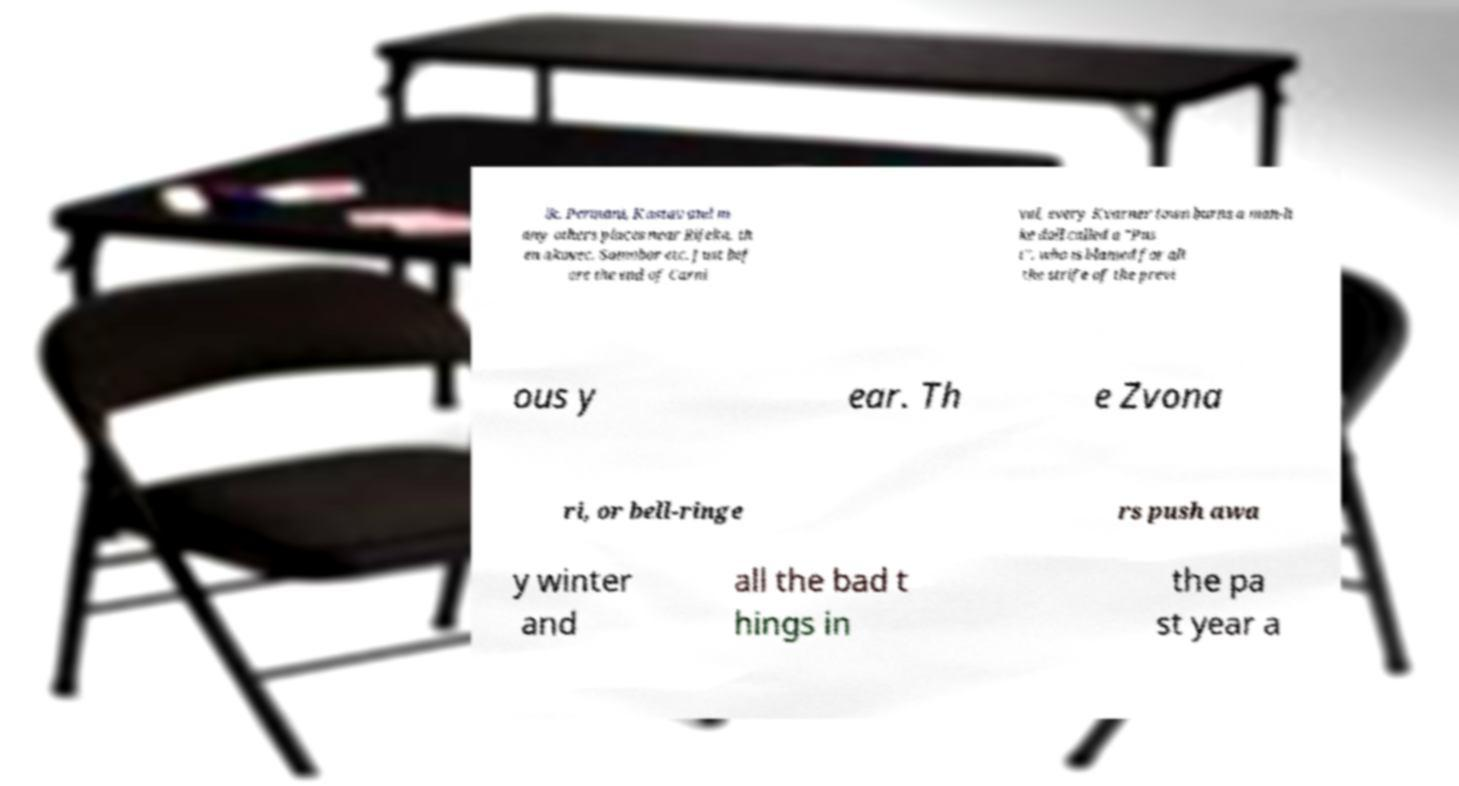For documentation purposes, I need the text within this image transcribed. Could you provide that? ik, Permani, Kastav and m any others places near Rijeka, th en akovec, Samobor etc. Just bef ore the end of Carni val, every Kvarner town burns a man-li ke doll called a "Pus t", who is blamed for all the strife of the previ ous y ear. Th e Zvona ri, or bell-ringe rs push awa y winter and all the bad t hings in the pa st year a 